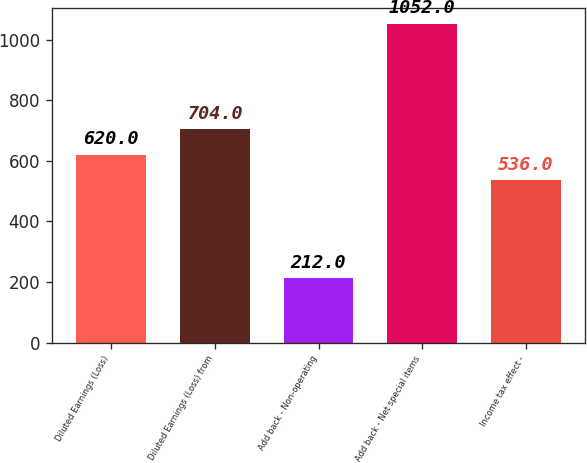<chart> <loc_0><loc_0><loc_500><loc_500><bar_chart><fcel>Diluted Earnings (Loss)<fcel>Diluted Earnings (Loss) from<fcel>Add back - Non-operating<fcel>Add back - Net special items<fcel>Income tax effect -<nl><fcel>620<fcel>704<fcel>212<fcel>1052<fcel>536<nl></chart> 